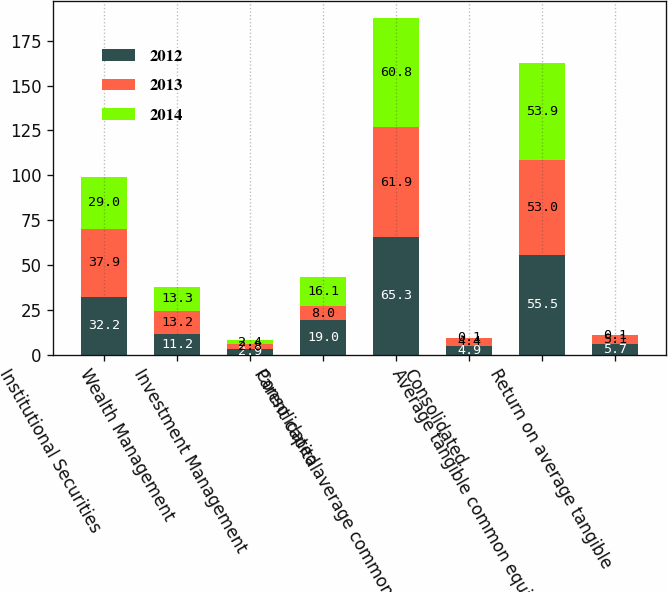Convert chart. <chart><loc_0><loc_0><loc_500><loc_500><stacked_bar_chart><ecel><fcel>Institutional Securities<fcel>Wealth Management<fcel>Investment Management<fcel>Parent capital<fcel>Consolidated average common<fcel>Consolidated<fcel>Average tangible common equity<fcel>Return on average tangible<nl><fcel>2012<fcel>32.2<fcel>11.2<fcel>2.9<fcel>19<fcel>65.3<fcel>4.9<fcel>55.5<fcel>5.7<nl><fcel>2013<fcel>37.9<fcel>13.2<fcel>2.8<fcel>8<fcel>61.9<fcel>4.4<fcel>53<fcel>5.1<nl><fcel>2014<fcel>29<fcel>13.3<fcel>2.4<fcel>16.1<fcel>60.8<fcel>0.1<fcel>53.9<fcel>0.1<nl></chart> 